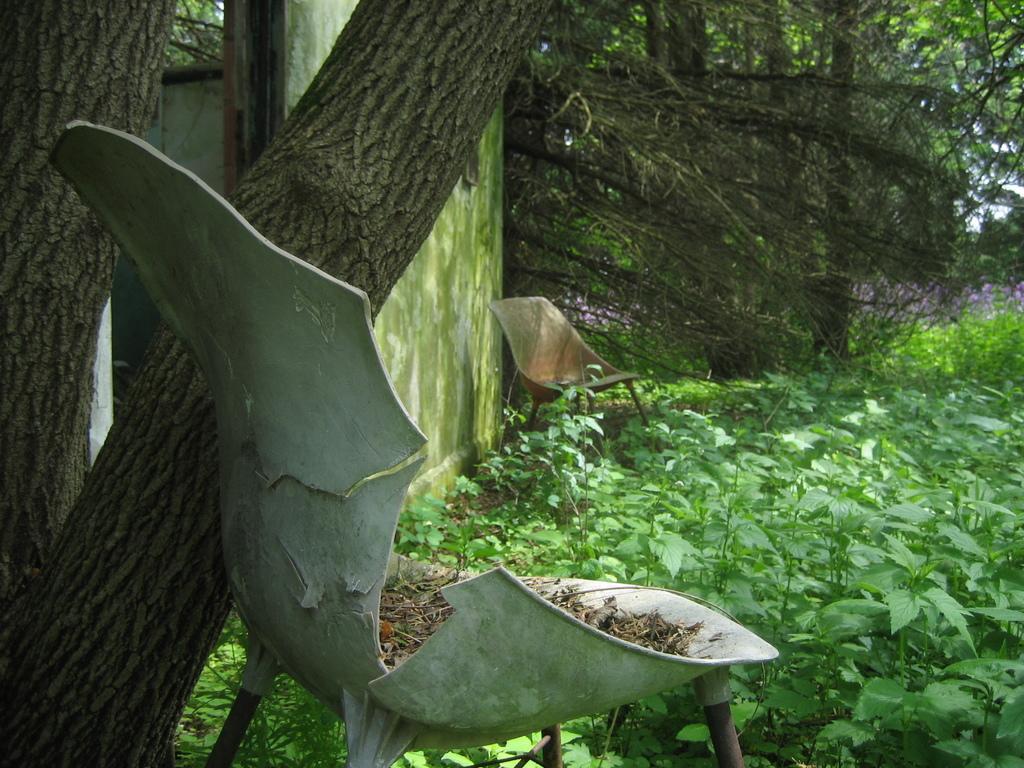Could you give a brief overview of what you see in this image? Here in this picture we can see plants and trees present on the ground and we can also see some old chairs also present. 